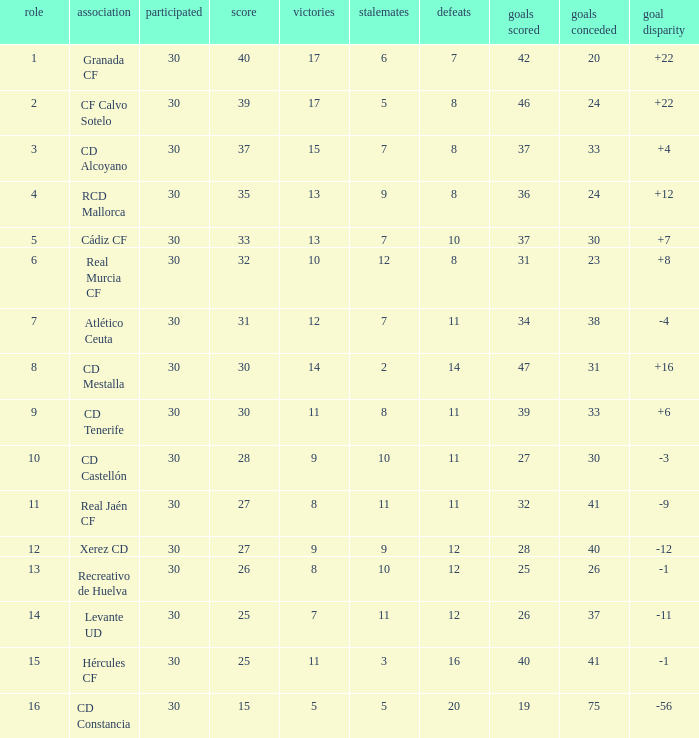How many Draws have 30 Points, and less than 33 Goals against? 1.0. 